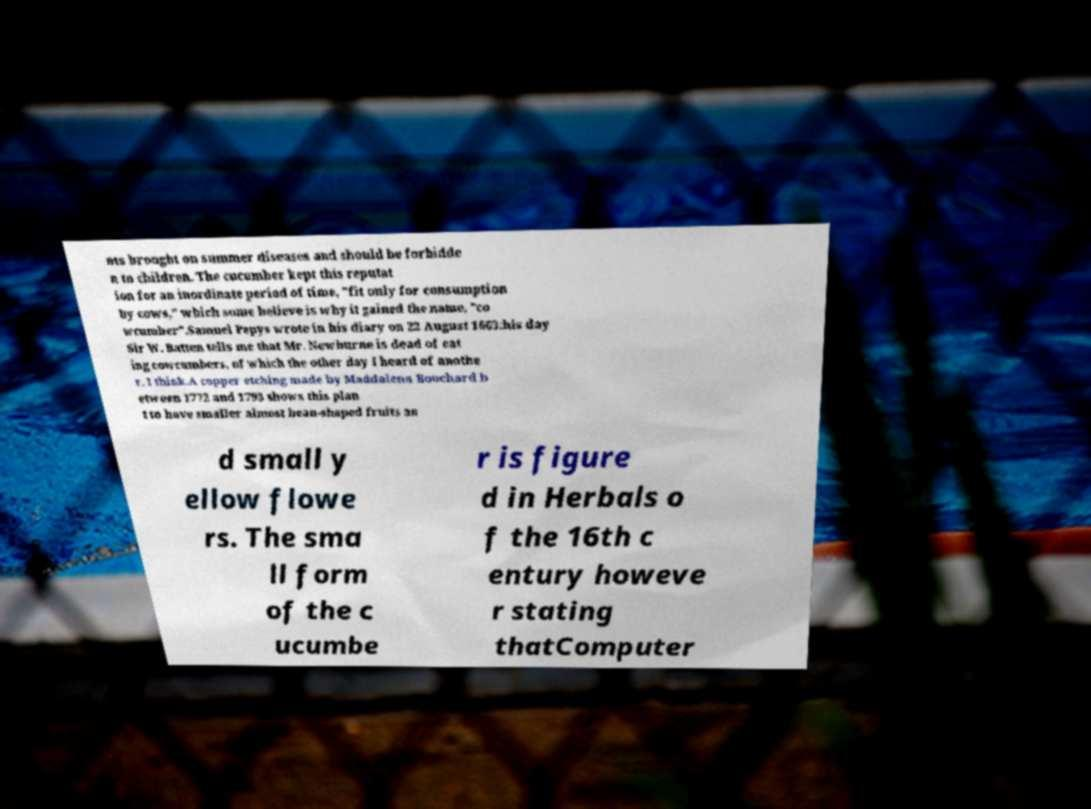For documentation purposes, I need the text within this image transcribed. Could you provide that? nts brought on summer diseases and should be forbidde n to children. The cucumber kept this reputat ion for an inordinate period of time, "fit only for consumption by cows," which some believe is why it gained the name, "co wcumber".Samuel Pepys wrote in his diary on 22 August 1663:his day Sir W. Batten tells me that Mr. Newburne is dead of eat ing cowcumbers, of which the other day I heard of anothe r, I think.A copper etching made by Maddalena Bouchard b etween 1772 and 1793 shows this plan t to have smaller almost bean-shaped fruits an d small y ellow flowe rs. The sma ll form of the c ucumbe r is figure d in Herbals o f the 16th c entury howeve r stating thatComputer 